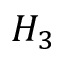Convert formula to latex. <formula><loc_0><loc_0><loc_500><loc_500>H _ { 3 }</formula> 